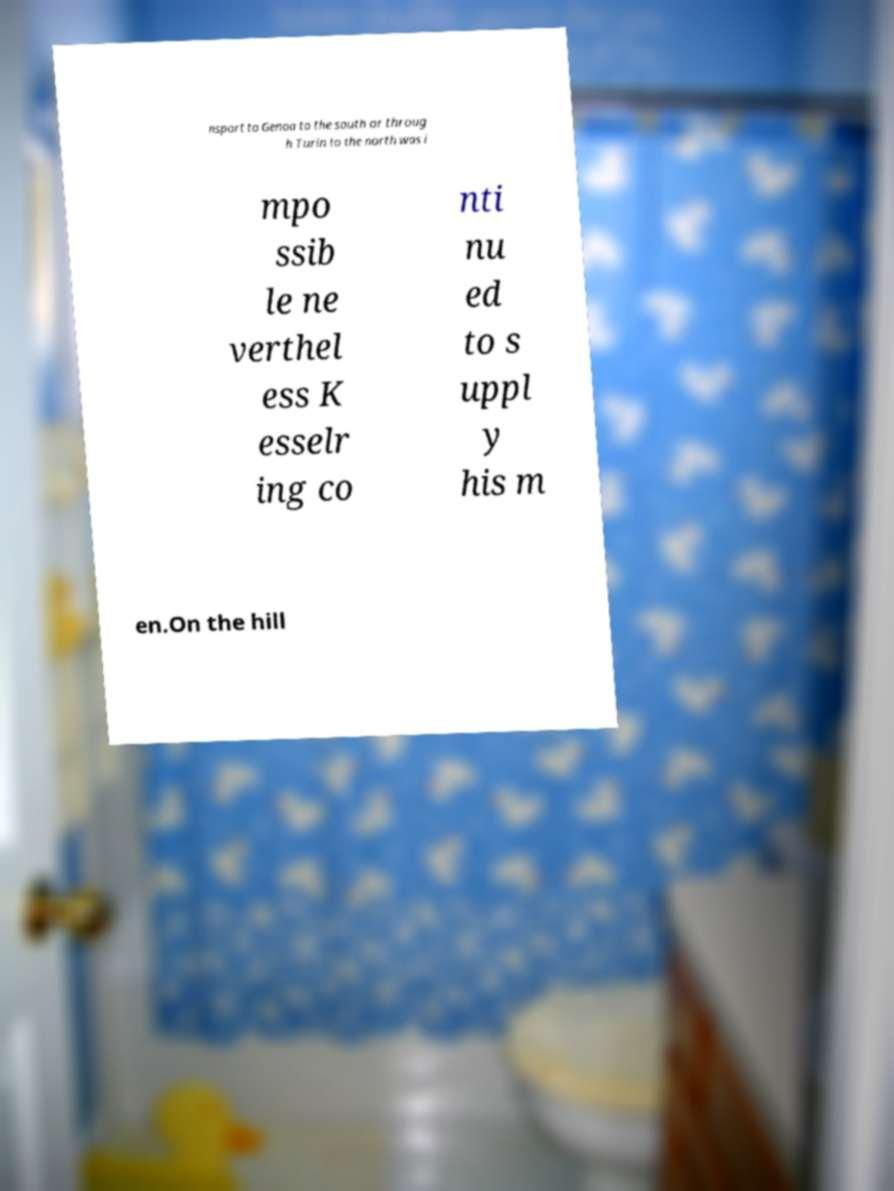Please read and relay the text visible in this image. What does it say? nsport to Genoa to the south or throug h Turin to the north was i mpo ssib le ne verthel ess K esselr ing co nti nu ed to s uppl y his m en.On the hill 